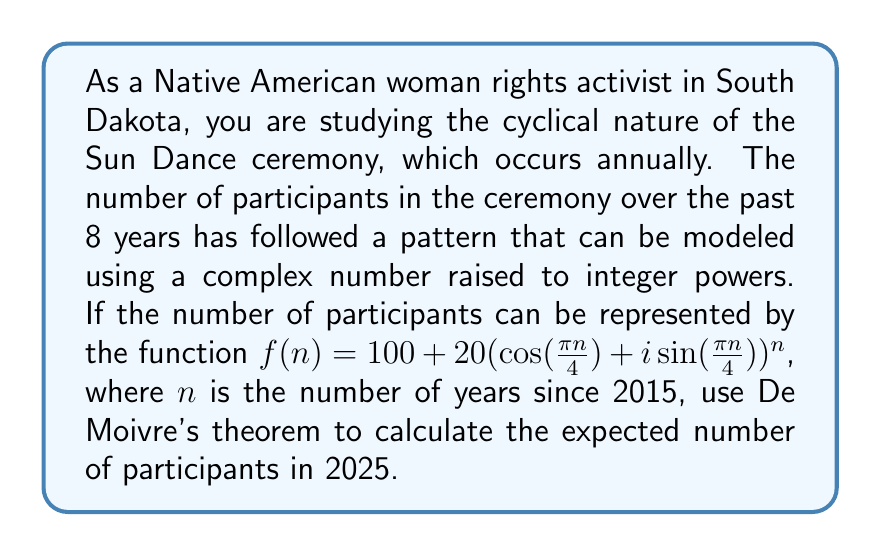Give your solution to this math problem. To solve this problem, we'll follow these steps:

1) First, we need to determine the value of $n$ for the year 2025. Since $n$ represents the number of years since 2015:
   $n = 2025 - 2015 = 10$

2) Now, we can plug this into our function:
   $f(10) = 100 + 20(\cos(\frac{\pi \cdot 10}{4}) + i\sin(\frac{\pi \cdot 10}{4}))^{10}$

3) Simplify the argument of cosine and sine:
   $f(10) = 100 + 20(\cos(\frac{5\pi}{2}) + i\sin(\frac{5\pi}{2}))^{10}$

4) We can use De Moivre's theorem here, which states that for any real number $x$ and integer $n$:
   $(\cos(x) + i\sin(x))^n = \cos(nx) + i\sin(nx)$

5) Applying this to our problem:
   $f(10) = 100 + 20(\cos(\frac{25\pi}{2}) + i\sin(\frac{25\pi}{2}))$

6) Simplify:
   $\cos(\frac{25\pi}{2}) = \cos(\frac{\pi}{2}) = 0$
   $\sin(\frac{25\pi}{2}) = \sin(\frac{\pi}{2}) = 1$

7) Therefore:
   $f(10) = 100 + 20(0 + i)$
   $f(10) = 100 + 20i$

8) The number of participants is represented by the real part of this complex number.
Answer: The expected number of participants in the Sun Dance ceremony in 2025 will be 100. 